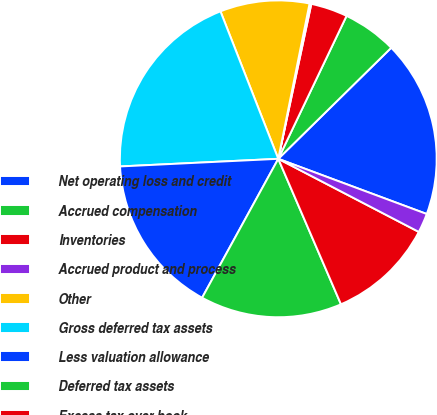<chart> <loc_0><loc_0><loc_500><loc_500><pie_chart><fcel>Net operating loss and credit<fcel>Accrued compensation<fcel>Inventories<fcel>Accrued product and process<fcel>Other<fcel>Gross deferred tax assets<fcel>Less valuation allowance<fcel>Deferred tax assets<fcel>Excess tax over book<fcel>Product and process technology<nl><fcel>18.03%<fcel>5.54%<fcel>3.75%<fcel>0.18%<fcel>9.11%<fcel>19.82%<fcel>16.25%<fcel>14.46%<fcel>10.89%<fcel>1.97%<nl></chart> 